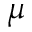<formula> <loc_0><loc_0><loc_500><loc_500>\mu</formula> 